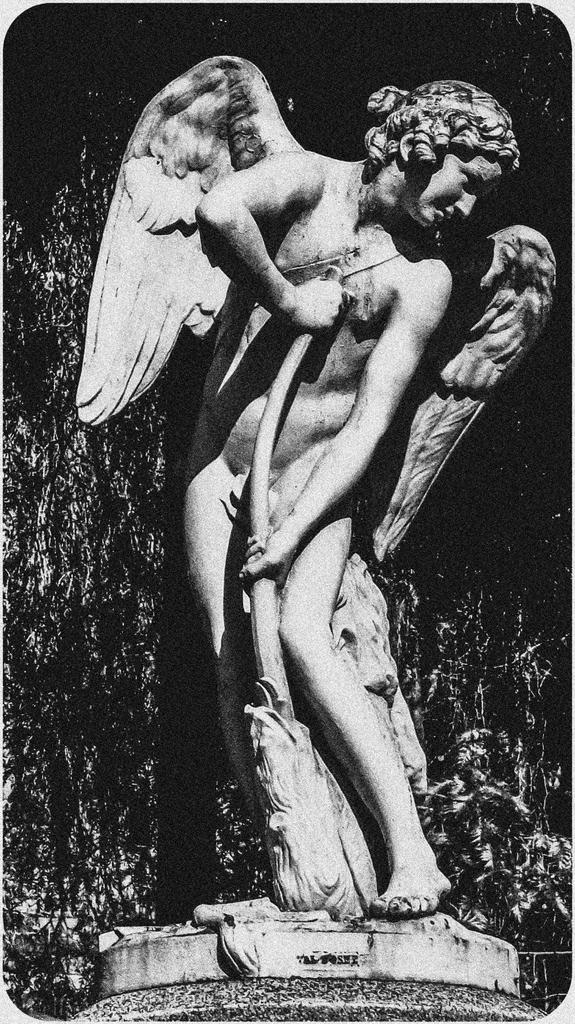What is the color scheme of the image? The image is black and white. What is the main subject in the center of the image? There is a statue in the center of the image. How would you describe the background of the image? The background of the image is dark. What type of growth can be seen on the statue's brain in the image? There is no mention of a brain or growth on the statue in the image, as the main subject is a statue and the image is black and white. 